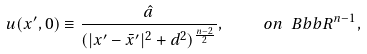<formula> <loc_0><loc_0><loc_500><loc_500>u ( x ^ { \prime } , 0 ) \equiv \frac { \hat { a } } { ( | x ^ { \prime } - \bar { x } ^ { \prime } | ^ { 2 } + d ^ { 2 } ) ^ { \frac { n - 2 } { 2 } } } , \quad o n \ B b b { R } ^ { n - 1 } ,</formula> 